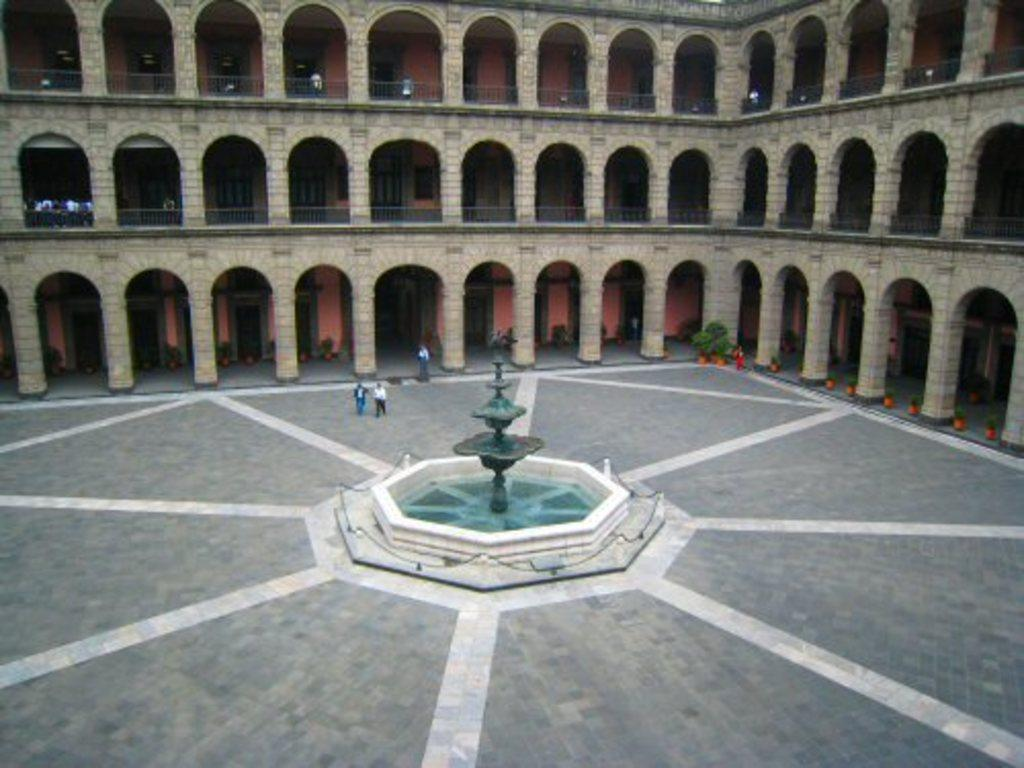What is the main structure in the center of the image? There is a building in the center of the image. Can you describe any other elements in the image? Yes, there are people visible in the image, as well as a fountain at the bottom. What is unique about the flower pots in the image? The flower pots have planets placed in them. What type of neck accessory is worn by the doll in the image? There is no doll present in the image, so it is not possible to determine what type of neck accessory it might be wearing. 